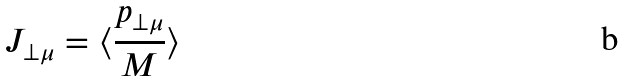Convert formula to latex. <formula><loc_0><loc_0><loc_500><loc_500>J _ { \perp \mu } = \langle \frac { p _ { \perp \mu } } { M } \rangle</formula> 